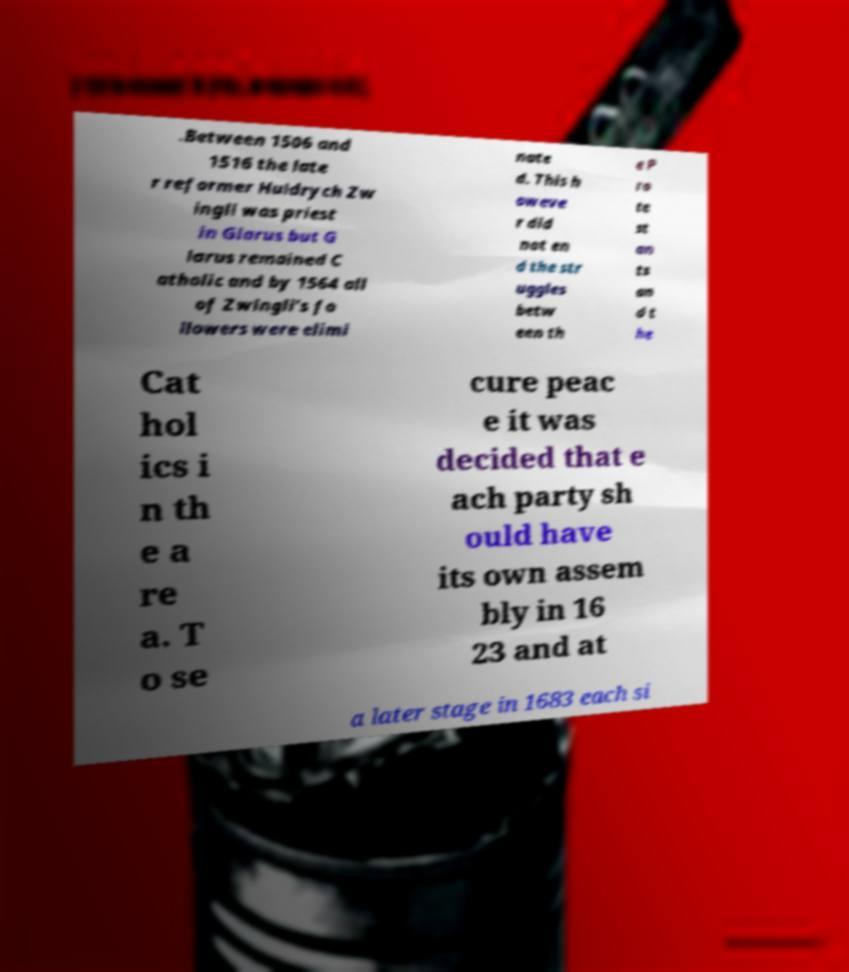For documentation purposes, I need the text within this image transcribed. Could you provide that? .Between 1506 and 1516 the late r reformer Huldrych Zw ingli was priest in Glarus but G larus remained C atholic and by 1564 all of Zwingli's fo llowers were elimi nate d. This h oweve r did not en d the str uggles betw een th e P ro te st an ts an d t he Cat hol ics i n th e a re a. T o se cure peac e it was decided that e ach party sh ould have its own assem bly in 16 23 and at a later stage in 1683 each si 